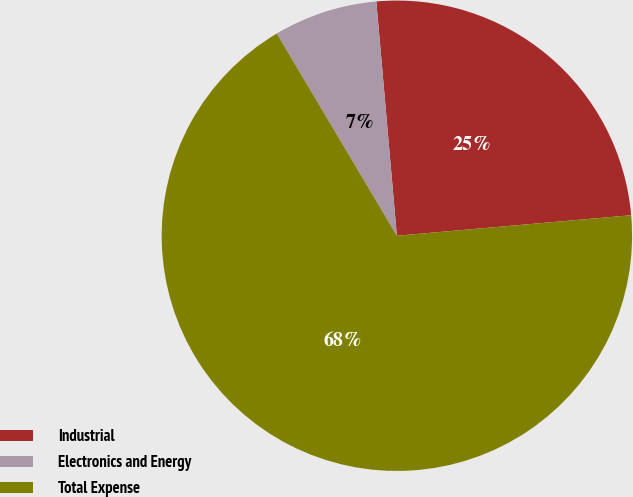Convert chart. <chart><loc_0><loc_0><loc_500><loc_500><pie_chart><fcel>Industrial<fcel>Electronics and Energy<fcel>Total Expense<nl><fcel>25.0%<fcel>7.14%<fcel>67.86%<nl></chart> 